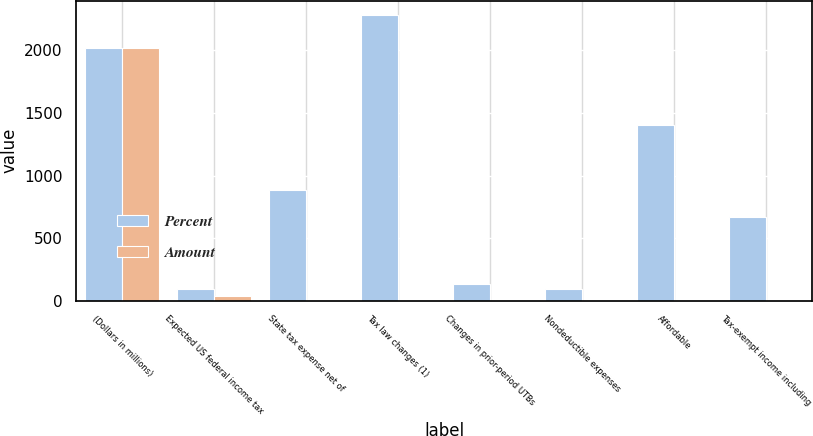<chart> <loc_0><loc_0><loc_500><loc_500><stacked_bar_chart><ecel><fcel>(Dollars in millions)<fcel>Expected US federal income tax<fcel>State tax expense net of<fcel>Tax law changes (1)<fcel>Changes in prior-period UTBs<fcel>Nondeductible expenses<fcel>Affordable<fcel>Tax-exempt income including<nl><fcel>Percent<fcel>2017<fcel>97<fcel>881<fcel>2281<fcel>133<fcel>97<fcel>1406<fcel>672<nl><fcel>Amount<fcel>2017<fcel>35<fcel>3<fcel>7.8<fcel>0.5<fcel>0.3<fcel>4.8<fcel>2.3<nl></chart> 